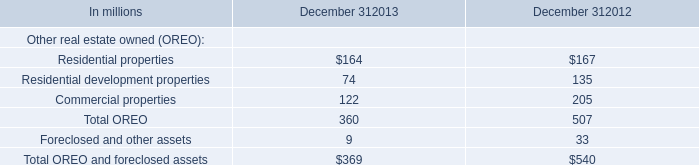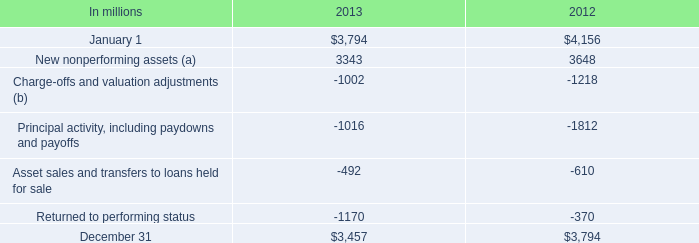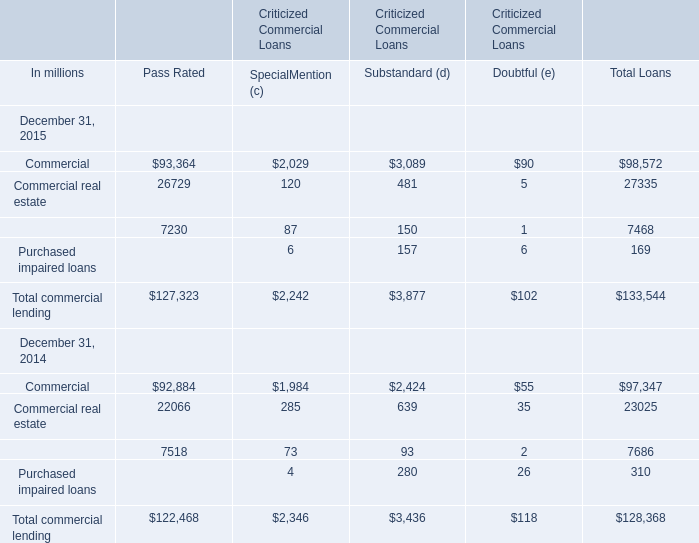What is the average amount of December 31 of 2012, and Equipment lease financing of Criticized Commercial Loans Pass Rated ? 
Computations: ((3794.0 + 7230.0) / 2)
Answer: 5512.0. 